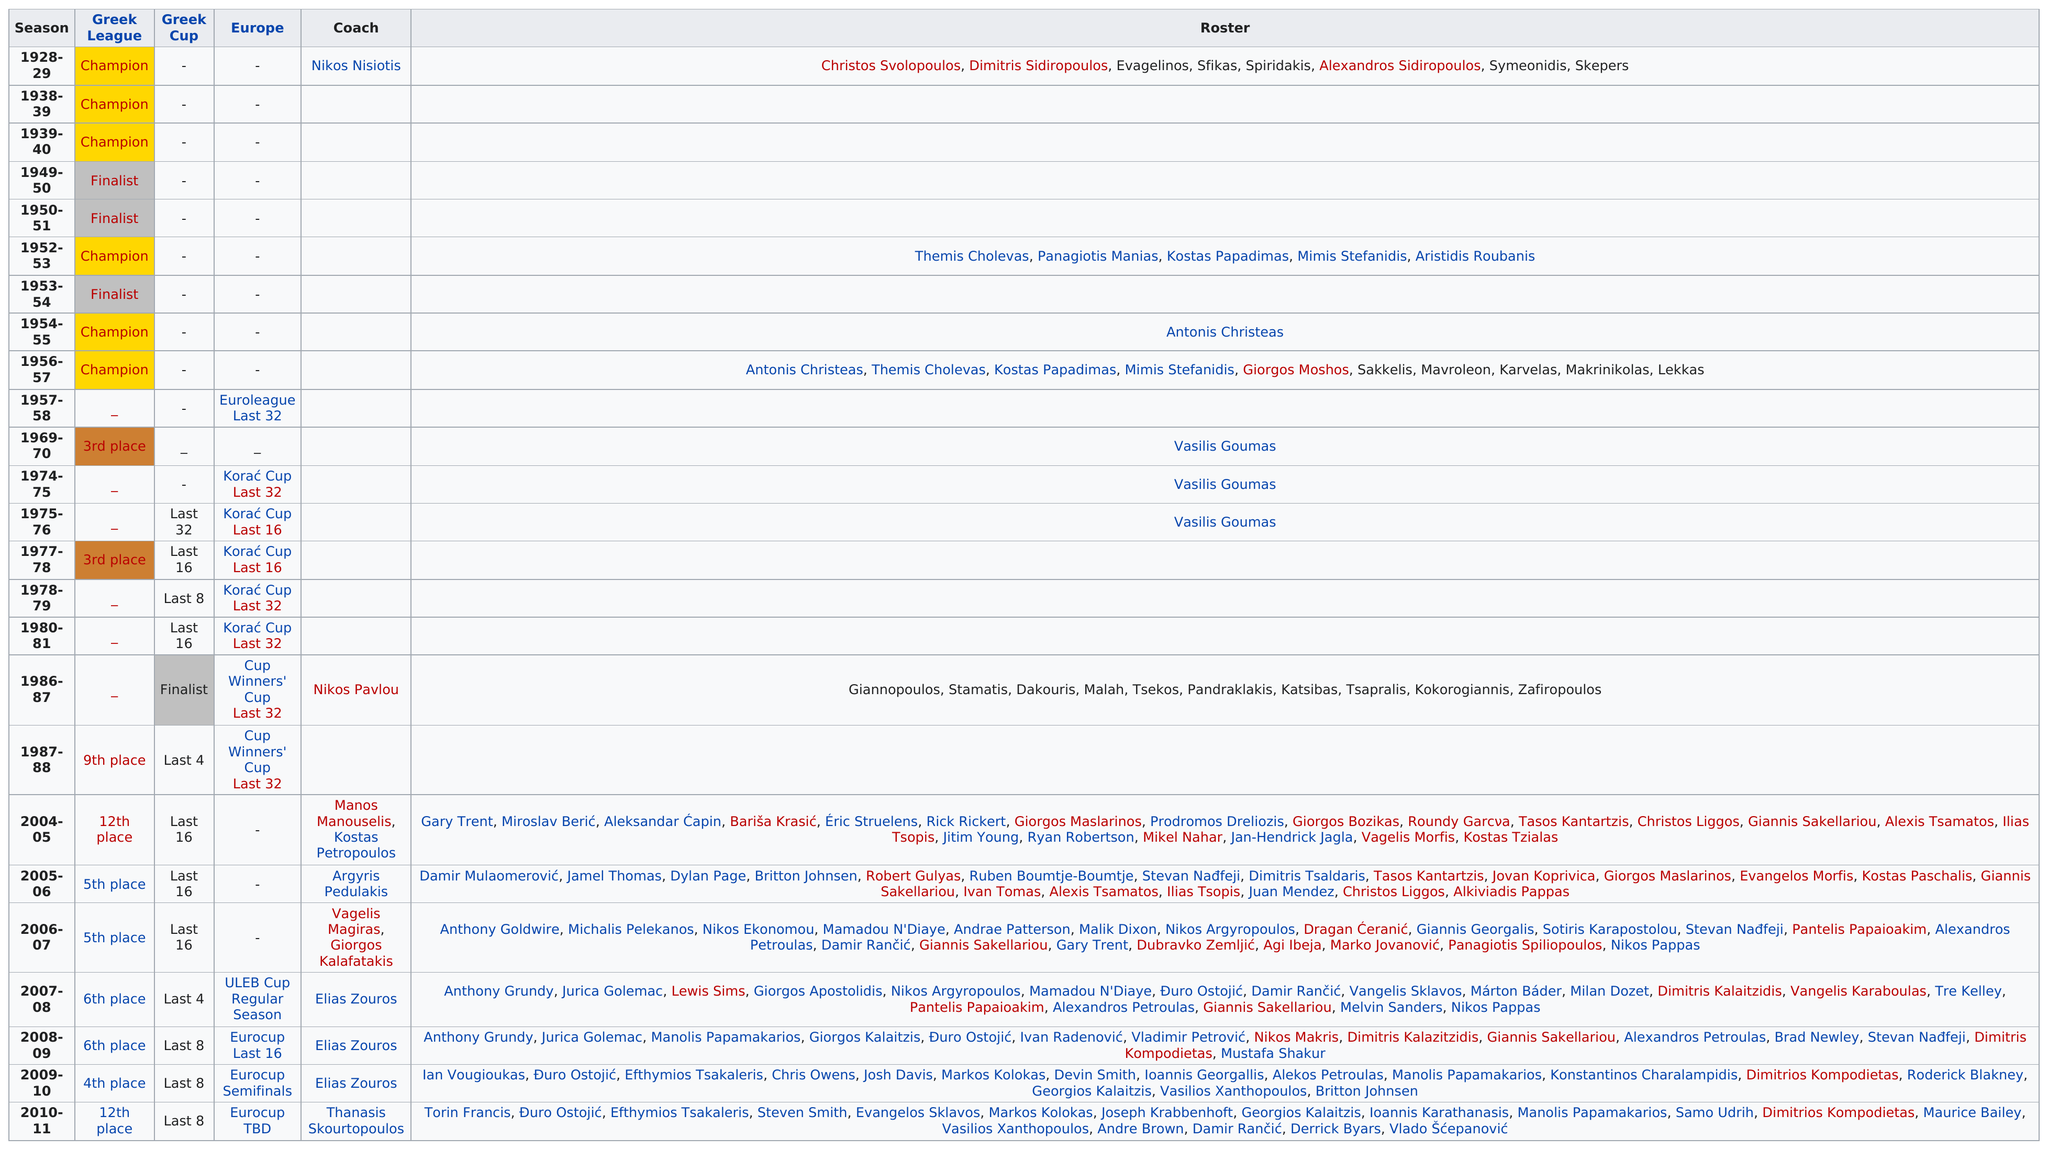Specify some key components in this picture. Nikos Pavlou, the Panellinios Basket coach, shares the same first name as Nikos Nisiotis. Vasilis Goumas and Antonis Christeas have both participated in multiple championships. Vasilis Goumas was a player on the roster from 1969 to 1976, and his name was spelled V-A-S-I-L-I-S G-O-U-M-A-S. Before 1986, there were only two Korac Cup Last 16 games played in Europe. In the 1950s, there were no Greek League finishes. However, other than that decade, there were 10 Greek League finishes. 